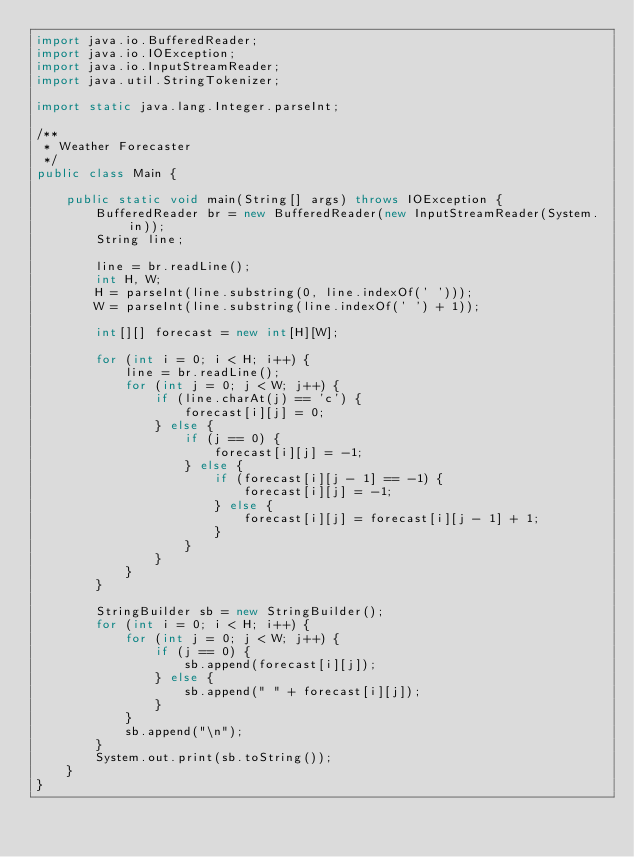Convert code to text. <code><loc_0><loc_0><loc_500><loc_500><_Java_>import java.io.BufferedReader;
import java.io.IOException;
import java.io.InputStreamReader;
import java.util.StringTokenizer;

import static java.lang.Integer.parseInt;

/**
 * Weather Forecaster
 */
public class Main {

	public static void main(String[] args) throws IOException {
		BufferedReader br = new BufferedReader(new InputStreamReader(System.in));
		String line;

		line = br.readLine();
		int H, W;
		H = parseInt(line.substring(0, line.indexOf(' ')));
		W = parseInt(line.substring(line.indexOf(' ') + 1));

		int[][] forecast = new int[H][W];

		for (int i = 0; i < H; i++) {
			line = br.readLine();
			for (int j = 0; j < W; j++) {
				if (line.charAt(j) == 'c') {
					forecast[i][j] = 0;
				} else {
					if (j == 0) {
						forecast[i][j] = -1;
					} else {
						if (forecast[i][j - 1] == -1) {
							forecast[i][j] = -1;
						} else {
							forecast[i][j] = forecast[i][j - 1] + 1;
						}
					}
				}
			}
		}

		StringBuilder sb = new StringBuilder();
		for (int i = 0; i < H; i++) {
			for (int j = 0; j < W; j++) {
				if (j == 0) {
					sb.append(forecast[i][j]);
				} else {
					sb.append(" " + forecast[i][j]);
				}
			}
			sb.append("\n");
		}
		System.out.print(sb.toString());
	}
}</code> 